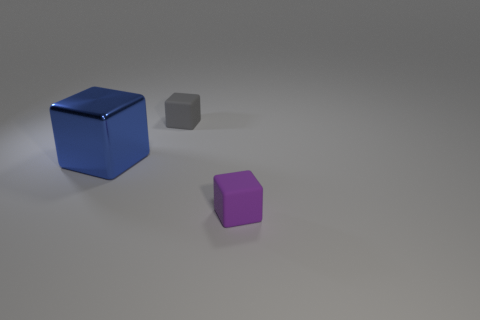Add 2 big purple cubes. How many objects exist? 5 Subtract all purple rubber things. Subtract all tiny rubber cubes. How many objects are left? 0 Add 3 large blue cubes. How many large blue cubes are left? 4 Add 3 tiny purple matte blocks. How many tiny purple matte blocks exist? 4 Subtract 0 cyan spheres. How many objects are left? 3 